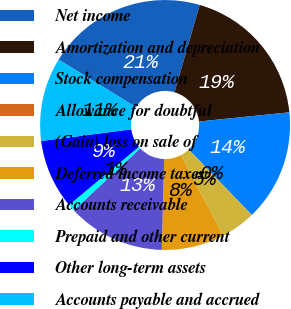Convert chart. <chart><loc_0><loc_0><loc_500><loc_500><pie_chart><fcel>Net income<fcel>Amortization and depreciation<fcel>Stock compensation<fcel>Allowance for doubtful<fcel>(Gain) loss on sale of<fcel>Deferred income taxes<fcel>Accounts receivable<fcel>Prepaid and other current<fcel>Other long-term assets<fcel>Accounts payable and accrued<nl><fcel>20.71%<fcel>18.91%<fcel>14.41%<fcel>0.01%<fcel>4.51%<fcel>8.11%<fcel>12.61%<fcel>0.91%<fcel>9.01%<fcel>10.81%<nl></chart> 